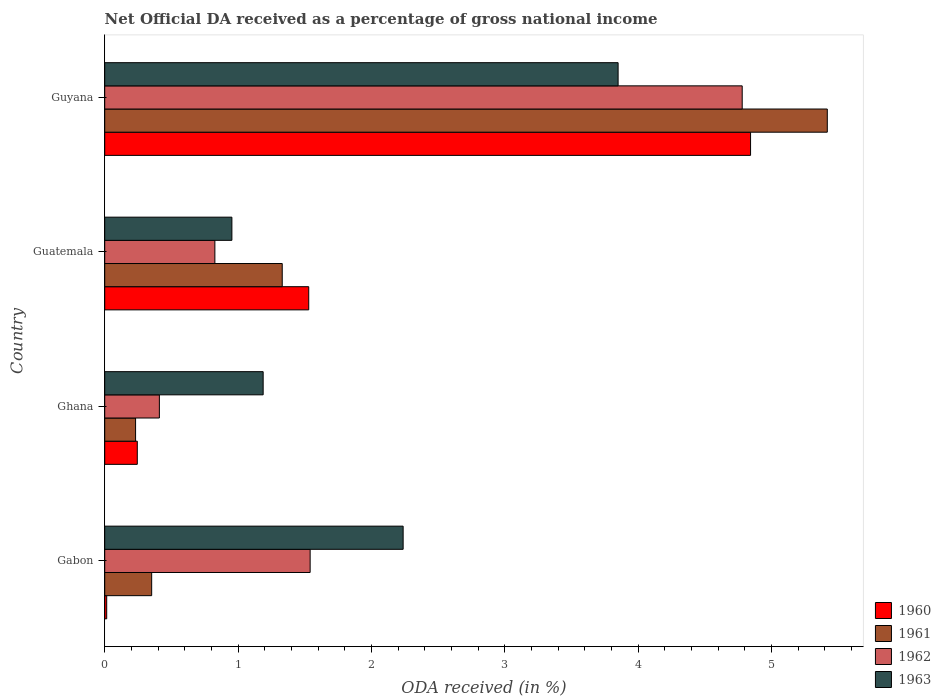How many different coloured bars are there?
Your answer should be very brief. 4. Are the number of bars per tick equal to the number of legend labels?
Your answer should be compact. Yes. Are the number of bars on each tick of the Y-axis equal?
Provide a short and direct response. Yes. What is the label of the 2nd group of bars from the top?
Your answer should be compact. Guatemala. What is the net official DA received in 1960 in Gabon?
Ensure brevity in your answer.  0.01. Across all countries, what is the maximum net official DA received in 1961?
Provide a succinct answer. 5.42. Across all countries, what is the minimum net official DA received in 1961?
Make the answer very short. 0.23. In which country was the net official DA received in 1962 maximum?
Provide a short and direct response. Guyana. In which country was the net official DA received in 1960 minimum?
Provide a succinct answer. Gabon. What is the total net official DA received in 1961 in the graph?
Keep it short and to the point. 7.33. What is the difference between the net official DA received in 1961 in Gabon and that in Guatemala?
Provide a short and direct response. -0.98. What is the difference between the net official DA received in 1961 in Ghana and the net official DA received in 1962 in Guatemala?
Provide a succinct answer. -0.59. What is the average net official DA received in 1961 per country?
Offer a terse response. 1.83. What is the difference between the net official DA received in 1961 and net official DA received in 1960 in Ghana?
Offer a very short reply. -0.01. In how many countries, is the net official DA received in 1961 greater than 4.4 %?
Offer a very short reply. 1. What is the ratio of the net official DA received in 1962 in Gabon to that in Ghana?
Offer a very short reply. 3.76. Is the net official DA received in 1962 in Ghana less than that in Guyana?
Provide a short and direct response. Yes. What is the difference between the highest and the second highest net official DA received in 1961?
Ensure brevity in your answer.  4.09. What is the difference between the highest and the lowest net official DA received in 1963?
Give a very brief answer. 2.9. Is the sum of the net official DA received in 1961 in Ghana and Guatemala greater than the maximum net official DA received in 1963 across all countries?
Keep it short and to the point. No. What does the 3rd bar from the top in Guatemala represents?
Provide a short and direct response. 1961. Is it the case that in every country, the sum of the net official DA received in 1960 and net official DA received in 1961 is greater than the net official DA received in 1962?
Make the answer very short. No. What is the difference between two consecutive major ticks on the X-axis?
Provide a succinct answer. 1. Does the graph contain any zero values?
Your answer should be compact. No. Does the graph contain grids?
Your response must be concise. No. Where does the legend appear in the graph?
Your response must be concise. Bottom right. How many legend labels are there?
Make the answer very short. 4. What is the title of the graph?
Ensure brevity in your answer.  Net Official DA received as a percentage of gross national income. Does "1962" appear as one of the legend labels in the graph?
Your answer should be compact. Yes. What is the label or title of the X-axis?
Offer a terse response. ODA received (in %). What is the label or title of the Y-axis?
Provide a short and direct response. Country. What is the ODA received (in %) in 1960 in Gabon?
Keep it short and to the point. 0.01. What is the ODA received (in %) of 1961 in Gabon?
Give a very brief answer. 0.35. What is the ODA received (in %) of 1962 in Gabon?
Make the answer very short. 1.54. What is the ODA received (in %) of 1963 in Gabon?
Your answer should be compact. 2.24. What is the ODA received (in %) of 1960 in Ghana?
Keep it short and to the point. 0.24. What is the ODA received (in %) in 1961 in Ghana?
Your answer should be very brief. 0.23. What is the ODA received (in %) in 1962 in Ghana?
Offer a very short reply. 0.41. What is the ODA received (in %) in 1963 in Ghana?
Give a very brief answer. 1.19. What is the ODA received (in %) in 1960 in Guatemala?
Your answer should be very brief. 1.53. What is the ODA received (in %) in 1961 in Guatemala?
Make the answer very short. 1.33. What is the ODA received (in %) in 1962 in Guatemala?
Give a very brief answer. 0.83. What is the ODA received (in %) in 1963 in Guatemala?
Ensure brevity in your answer.  0.95. What is the ODA received (in %) in 1960 in Guyana?
Provide a succinct answer. 4.84. What is the ODA received (in %) of 1961 in Guyana?
Offer a terse response. 5.42. What is the ODA received (in %) in 1962 in Guyana?
Give a very brief answer. 4.78. What is the ODA received (in %) in 1963 in Guyana?
Give a very brief answer. 3.85. Across all countries, what is the maximum ODA received (in %) in 1960?
Ensure brevity in your answer.  4.84. Across all countries, what is the maximum ODA received (in %) of 1961?
Keep it short and to the point. 5.42. Across all countries, what is the maximum ODA received (in %) of 1962?
Your answer should be very brief. 4.78. Across all countries, what is the maximum ODA received (in %) of 1963?
Give a very brief answer. 3.85. Across all countries, what is the minimum ODA received (in %) in 1960?
Provide a succinct answer. 0.01. Across all countries, what is the minimum ODA received (in %) of 1961?
Provide a succinct answer. 0.23. Across all countries, what is the minimum ODA received (in %) in 1962?
Offer a very short reply. 0.41. Across all countries, what is the minimum ODA received (in %) in 1963?
Offer a very short reply. 0.95. What is the total ODA received (in %) of 1960 in the graph?
Your answer should be very brief. 6.63. What is the total ODA received (in %) of 1961 in the graph?
Provide a short and direct response. 7.33. What is the total ODA received (in %) of 1962 in the graph?
Ensure brevity in your answer.  7.56. What is the total ODA received (in %) in 1963 in the graph?
Provide a short and direct response. 8.23. What is the difference between the ODA received (in %) of 1960 in Gabon and that in Ghana?
Offer a terse response. -0.23. What is the difference between the ODA received (in %) of 1961 in Gabon and that in Ghana?
Offer a very short reply. 0.12. What is the difference between the ODA received (in %) in 1962 in Gabon and that in Ghana?
Give a very brief answer. 1.13. What is the difference between the ODA received (in %) of 1963 in Gabon and that in Ghana?
Make the answer very short. 1.05. What is the difference between the ODA received (in %) of 1960 in Gabon and that in Guatemala?
Keep it short and to the point. -1.52. What is the difference between the ODA received (in %) of 1961 in Gabon and that in Guatemala?
Make the answer very short. -0.98. What is the difference between the ODA received (in %) in 1962 in Gabon and that in Guatemala?
Make the answer very short. 0.71. What is the difference between the ODA received (in %) of 1963 in Gabon and that in Guatemala?
Provide a succinct answer. 1.28. What is the difference between the ODA received (in %) in 1960 in Gabon and that in Guyana?
Your answer should be compact. -4.83. What is the difference between the ODA received (in %) in 1961 in Gabon and that in Guyana?
Make the answer very short. -5.07. What is the difference between the ODA received (in %) of 1962 in Gabon and that in Guyana?
Provide a succinct answer. -3.24. What is the difference between the ODA received (in %) in 1963 in Gabon and that in Guyana?
Offer a terse response. -1.61. What is the difference between the ODA received (in %) of 1960 in Ghana and that in Guatemala?
Offer a very short reply. -1.29. What is the difference between the ODA received (in %) in 1961 in Ghana and that in Guatemala?
Provide a short and direct response. -1.1. What is the difference between the ODA received (in %) of 1962 in Ghana and that in Guatemala?
Make the answer very short. -0.42. What is the difference between the ODA received (in %) of 1963 in Ghana and that in Guatemala?
Provide a short and direct response. 0.23. What is the difference between the ODA received (in %) in 1960 in Ghana and that in Guyana?
Provide a short and direct response. -4.6. What is the difference between the ODA received (in %) in 1961 in Ghana and that in Guyana?
Offer a very short reply. -5.19. What is the difference between the ODA received (in %) of 1962 in Ghana and that in Guyana?
Keep it short and to the point. -4.37. What is the difference between the ODA received (in %) of 1963 in Ghana and that in Guyana?
Provide a short and direct response. -2.66. What is the difference between the ODA received (in %) of 1960 in Guatemala and that in Guyana?
Provide a succinct answer. -3.31. What is the difference between the ODA received (in %) in 1961 in Guatemala and that in Guyana?
Give a very brief answer. -4.09. What is the difference between the ODA received (in %) of 1962 in Guatemala and that in Guyana?
Your answer should be compact. -3.96. What is the difference between the ODA received (in %) in 1963 in Guatemala and that in Guyana?
Give a very brief answer. -2.9. What is the difference between the ODA received (in %) in 1960 in Gabon and the ODA received (in %) in 1961 in Ghana?
Make the answer very short. -0.22. What is the difference between the ODA received (in %) of 1960 in Gabon and the ODA received (in %) of 1962 in Ghana?
Offer a very short reply. -0.4. What is the difference between the ODA received (in %) in 1960 in Gabon and the ODA received (in %) in 1963 in Ghana?
Your answer should be very brief. -1.17. What is the difference between the ODA received (in %) in 1961 in Gabon and the ODA received (in %) in 1962 in Ghana?
Your answer should be compact. -0.06. What is the difference between the ODA received (in %) in 1961 in Gabon and the ODA received (in %) in 1963 in Ghana?
Make the answer very short. -0.84. What is the difference between the ODA received (in %) of 1962 in Gabon and the ODA received (in %) of 1963 in Ghana?
Your answer should be compact. 0.35. What is the difference between the ODA received (in %) of 1960 in Gabon and the ODA received (in %) of 1961 in Guatemala?
Ensure brevity in your answer.  -1.32. What is the difference between the ODA received (in %) of 1960 in Gabon and the ODA received (in %) of 1962 in Guatemala?
Your answer should be very brief. -0.81. What is the difference between the ODA received (in %) in 1960 in Gabon and the ODA received (in %) in 1963 in Guatemala?
Give a very brief answer. -0.94. What is the difference between the ODA received (in %) of 1961 in Gabon and the ODA received (in %) of 1962 in Guatemala?
Provide a succinct answer. -0.47. What is the difference between the ODA received (in %) of 1961 in Gabon and the ODA received (in %) of 1963 in Guatemala?
Offer a very short reply. -0.6. What is the difference between the ODA received (in %) of 1962 in Gabon and the ODA received (in %) of 1963 in Guatemala?
Your answer should be very brief. 0.59. What is the difference between the ODA received (in %) of 1960 in Gabon and the ODA received (in %) of 1961 in Guyana?
Provide a succinct answer. -5.4. What is the difference between the ODA received (in %) in 1960 in Gabon and the ODA received (in %) in 1962 in Guyana?
Give a very brief answer. -4.77. What is the difference between the ODA received (in %) of 1960 in Gabon and the ODA received (in %) of 1963 in Guyana?
Your answer should be compact. -3.84. What is the difference between the ODA received (in %) of 1961 in Gabon and the ODA received (in %) of 1962 in Guyana?
Ensure brevity in your answer.  -4.43. What is the difference between the ODA received (in %) in 1961 in Gabon and the ODA received (in %) in 1963 in Guyana?
Keep it short and to the point. -3.5. What is the difference between the ODA received (in %) in 1962 in Gabon and the ODA received (in %) in 1963 in Guyana?
Make the answer very short. -2.31. What is the difference between the ODA received (in %) in 1960 in Ghana and the ODA received (in %) in 1961 in Guatemala?
Offer a very short reply. -1.09. What is the difference between the ODA received (in %) of 1960 in Ghana and the ODA received (in %) of 1962 in Guatemala?
Provide a short and direct response. -0.58. What is the difference between the ODA received (in %) of 1960 in Ghana and the ODA received (in %) of 1963 in Guatemala?
Your answer should be very brief. -0.71. What is the difference between the ODA received (in %) of 1961 in Ghana and the ODA received (in %) of 1962 in Guatemala?
Offer a very short reply. -0.59. What is the difference between the ODA received (in %) of 1961 in Ghana and the ODA received (in %) of 1963 in Guatemala?
Make the answer very short. -0.72. What is the difference between the ODA received (in %) of 1962 in Ghana and the ODA received (in %) of 1963 in Guatemala?
Offer a very short reply. -0.54. What is the difference between the ODA received (in %) in 1960 in Ghana and the ODA received (in %) in 1961 in Guyana?
Offer a very short reply. -5.18. What is the difference between the ODA received (in %) of 1960 in Ghana and the ODA received (in %) of 1962 in Guyana?
Offer a terse response. -4.54. What is the difference between the ODA received (in %) in 1960 in Ghana and the ODA received (in %) in 1963 in Guyana?
Ensure brevity in your answer.  -3.61. What is the difference between the ODA received (in %) of 1961 in Ghana and the ODA received (in %) of 1962 in Guyana?
Ensure brevity in your answer.  -4.55. What is the difference between the ODA received (in %) in 1961 in Ghana and the ODA received (in %) in 1963 in Guyana?
Ensure brevity in your answer.  -3.62. What is the difference between the ODA received (in %) in 1962 in Ghana and the ODA received (in %) in 1963 in Guyana?
Keep it short and to the point. -3.44. What is the difference between the ODA received (in %) in 1960 in Guatemala and the ODA received (in %) in 1961 in Guyana?
Your answer should be compact. -3.89. What is the difference between the ODA received (in %) of 1960 in Guatemala and the ODA received (in %) of 1962 in Guyana?
Keep it short and to the point. -3.25. What is the difference between the ODA received (in %) of 1960 in Guatemala and the ODA received (in %) of 1963 in Guyana?
Offer a terse response. -2.32. What is the difference between the ODA received (in %) of 1961 in Guatemala and the ODA received (in %) of 1962 in Guyana?
Provide a short and direct response. -3.45. What is the difference between the ODA received (in %) in 1961 in Guatemala and the ODA received (in %) in 1963 in Guyana?
Provide a short and direct response. -2.52. What is the difference between the ODA received (in %) in 1962 in Guatemala and the ODA received (in %) in 1963 in Guyana?
Provide a short and direct response. -3.02. What is the average ODA received (in %) in 1960 per country?
Your response must be concise. 1.66. What is the average ODA received (in %) of 1961 per country?
Offer a very short reply. 1.83. What is the average ODA received (in %) of 1962 per country?
Your answer should be very brief. 1.89. What is the average ODA received (in %) in 1963 per country?
Your answer should be compact. 2.06. What is the difference between the ODA received (in %) of 1960 and ODA received (in %) of 1961 in Gabon?
Provide a succinct answer. -0.34. What is the difference between the ODA received (in %) of 1960 and ODA received (in %) of 1962 in Gabon?
Ensure brevity in your answer.  -1.53. What is the difference between the ODA received (in %) in 1960 and ODA received (in %) in 1963 in Gabon?
Ensure brevity in your answer.  -2.22. What is the difference between the ODA received (in %) of 1961 and ODA received (in %) of 1962 in Gabon?
Keep it short and to the point. -1.19. What is the difference between the ODA received (in %) in 1961 and ODA received (in %) in 1963 in Gabon?
Ensure brevity in your answer.  -1.89. What is the difference between the ODA received (in %) in 1962 and ODA received (in %) in 1963 in Gabon?
Your answer should be very brief. -0.7. What is the difference between the ODA received (in %) in 1960 and ODA received (in %) in 1961 in Ghana?
Your answer should be very brief. 0.01. What is the difference between the ODA received (in %) of 1960 and ODA received (in %) of 1962 in Ghana?
Make the answer very short. -0.17. What is the difference between the ODA received (in %) of 1960 and ODA received (in %) of 1963 in Ghana?
Offer a terse response. -0.94. What is the difference between the ODA received (in %) of 1961 and ODA received (in %) of 1962 in Ghana?
Provide a short and direct response. -0.18. What is the difference between the ODA received (in %) of 1961 and ODA received (in %) of 1963 in Ghana?
Your answer should be very brief. -0.96. What is the difference between the ODA received (in %) in 1962 and ODA received (in %) in 1963 in Ghana?
Your answer should be very brief. -0.78. What is the difference between the ODA received (in %) of 1960 and ODA received (in %) of 1961 in Guatemala?
Offer a very short reply. 0.2. What is the difference between the ODA received (in %) of 1960 and ODA received (in %) of 1962 in Guatemala?
Keep it short and to the point. 0.7. What is the difference between the ODA received (in %) of 1960 and ODA received (in %) of 1963 in Guatemala?
Your response must be concise. 0.58. What is the difference between the ODA received (in %) of 1961 and ODA received (in %) of 1962 in Guatemala?
Make the answer very short. 0.51. What is the difference between the ODA received (in %) of 1961 and ODA received (in %) of 1963 in Guatemala?
Provide a succinct answer. 0.38. What is the difference between the ODA received (in %) in 1962 and ODA received (in %) in 1963 in Guatemala?
Your answer should be very brief. -0.13. What is the difference between the ODA received (in %) in 1960 and ODA received (in %) in 1961 in Guyana?
Your answer should be very brief. -0.58. What is the difference between the ODA received (in %) of 1960 and ODA received (in %) of 1962 in Guyana?
Offer a very short reply. 0.06. What is the difference between the ODA received (in %) in 1960 and ODA received (in %) in 1963 in Guyana?
Your response must be concise. 0.99. What is the difference between the ODA received (in %) of 1961 and ODA received (in %) of 1962 in Guyana?
Give a very brief answer. 0.64. What is the difference between the ODA received (in %) of 1961 and ODA received (in %) of 1963 in Guyana?
Give a very brief answer. 1.57. What is the difference between the ODA received (in %) of 1962 and ODA received (in %) of 1963 in Guyana?
Give a very brief answer. 0.93. What is the ratio of the ODA received (in %) in 1960 in Gabon to that in Ghana?
Your answer should be very brief. 0.06. What is the ratio of the ODA received (in %) in 1961 in Gabon to that in Ghana?
Offer a terse response. 1.52. What is the ratio of the ODA received (in %) in 1962 in Gabon to that in Ghana?
Provide a short and direct response. 3.76. What is the ratio of the ODA received (in %) of 1963 in Gabon to that in Ghana?
Make the answer very short. 1.88. What is the ratio of the ODA received (in %) of 1960 in Gabon to that in Guatemala?
Provide a short and direct response. 0.01. What is the ratio of the ODA received (in %) in 1961 in Gabon to that in Guatemala?
Provide a short and direct response. 0.26. What is the ratio of the ODA received (in %) of 1962 in Gabon to that in Guatemala?
Your response must be concise. 1.86. What is the ratio of the ODA received (in %) of 1963 in Gabon to that in Guatemala?
Keep it short and to the point. 2.35. What is the ratio of the ODA received (in %) in 1960 in Gabon to that in Guyana?
Make the answer very short. 0. What is the ratio of the ODA received (in %) of 1961 in Gabon to that in Guyana?
Keep it short and to the point. 0.07. What is the ratio of the ODA received (in %) in 1962 in Gabon to that in Guyana?
Offer a very short reply. 0.32. What is the ratio of the ODA received (in %) of 1963 in Gabon to that in Guyana?
Give a very brief answer. 0.58. What is the ratio of the ODA received (in %) in 1960 in Ghana to that in Guatemala?
Make the answer very short. 0.16. What is the ratio of the ODA received (in %) of 1961 in Ghana to that in Guatemala?
Your answer should be very brief. 0.17. What is the ratio of the ODA received (in %) of 1962 in Ghana to that in Guatemala?
Keep it short and to the point. 0.5. What is the ratio of the ODA received (in %) of 1963 in Ghana to that in Guatemala?
Provide a succinct answer. 1.25. What is the ratio of the ODA received (in %) in 1960 in Ghana to that in Guyana?
Give a very brief answer. 0.05. What is the ratio of the ODA received (in %) of 1961 in Ghana to that in Guyana?
Your response must be concise. 0.04. What is the ratio of the ODA received (in %) in 1962 in Ghana to that in Guyana?
Ensure brevity in your answer.  0.09. What is the ratio of the ODA received (in %) in 1963 in Ghana to that in Guyana?
Offer a terse response. 0.31. What is the ratio of the ODA received (in %) of 1960 in Guatemala to that in Guyana?
Your answer should be compact. 0.32. What is the ratio of the ODA received (in %) in 1961 in Guatemala to that in Guyana?
Provide a succinct answer. 0.25. What is the ratio of the ODA received (in %) of 1962 in Guatemala to that in Guyana?
Provide a short and direct response. 0.17. What is the ratio of the ODA received (in %) in 1963 in Guatemala to that in Guyana?
Offer a very short reply. 0.25. What is the difference between the highest and the second highest ODA received (in %) of 1960?
Provide a succinct answer. 3.31. What is the difference between the highest and the second highest ODA received (in %) in 1961?
Your answer should be very brief. 4.09. What is the difference between the highest and the second highest ODA received (in %) of 1962?
Provide a succinct answer. 3.24. What is the difference between the highest and the second highest ODA received (in %) of 1963?
Ensure brevity in your answer.  1.61. What is the difference between the highest and the lowest ODA received (in %) in 1960?
Offer a very short reply. 4.83. What is the difference between the highest and the lowest ODA received (in %) in 1961?
Keep it short and to the point. 5.19. What is the difference between the highest and the lowest ODA received (in %) in 1962?
Your answer should be compact. 4.37. What is the difference between the highest and the lowest ODA received (in %) of 1963?
Give a very brief answer. 2.9. 